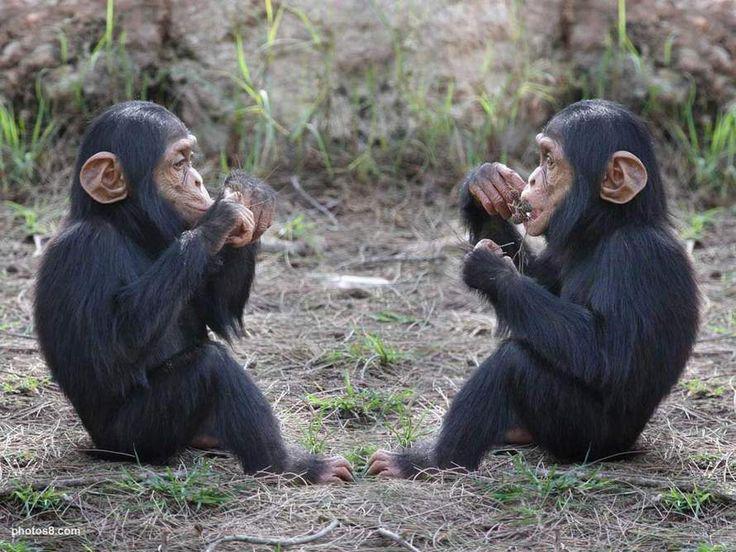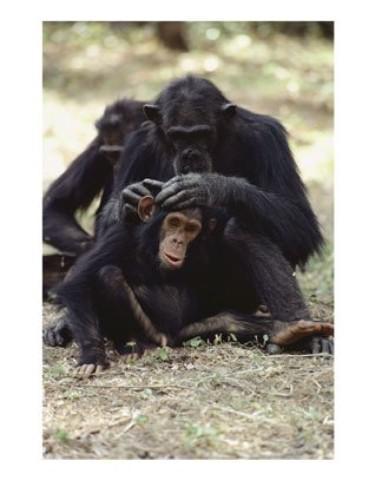The first image is the image on the left, the second image is the image on the right. Given the left and right images, does the statement "There is exactly three chimpanzees in the right image." hold true? Answer yes or no. Yes. The first image is the image on the left, the second image is the image on the right. Given the left and right images, does the statement "One image includes two apes sitting directly face to face, while the other image features chimps sitting one behind the other." hold true? Answer yes or no. Yes. 